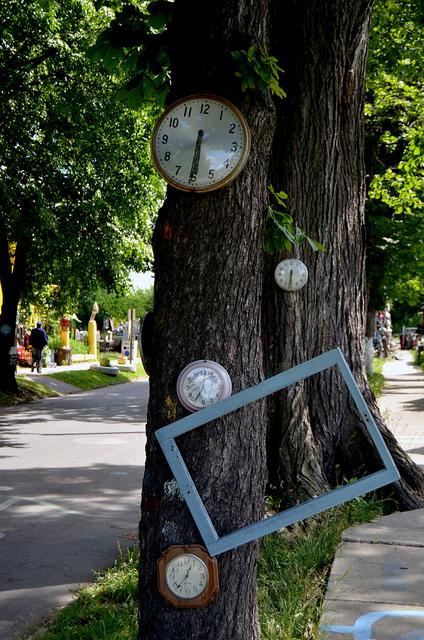What color is the picture frame?
Keep it brief. Blue. How many clocks are on the tree?
Keep it brief. 4. What are the clocks hanging on?
Answer briefly. Tree. 